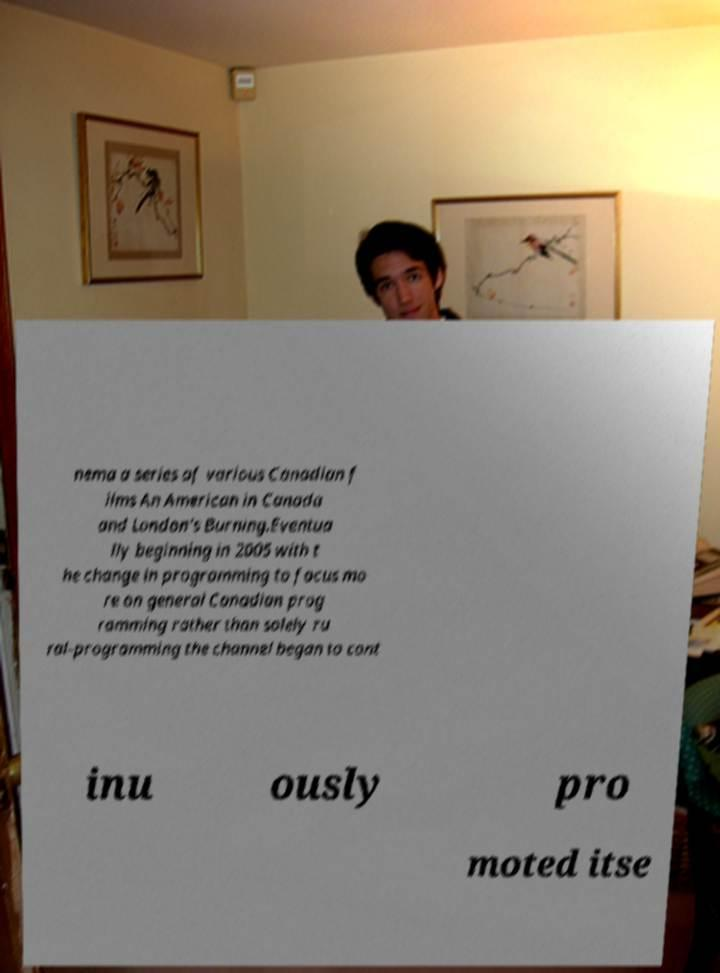Could you assist in decoding the text presented in this image and type it out clearly? nema a series of various Canadian f ilms An American in Canada and London's Burning.Eventua lly beginning in 2005 with t he change in programming to focus mo re on general Canadian prog ramming rather than solely ru ral-programming the channel began to cont inu ously pro moted itse 